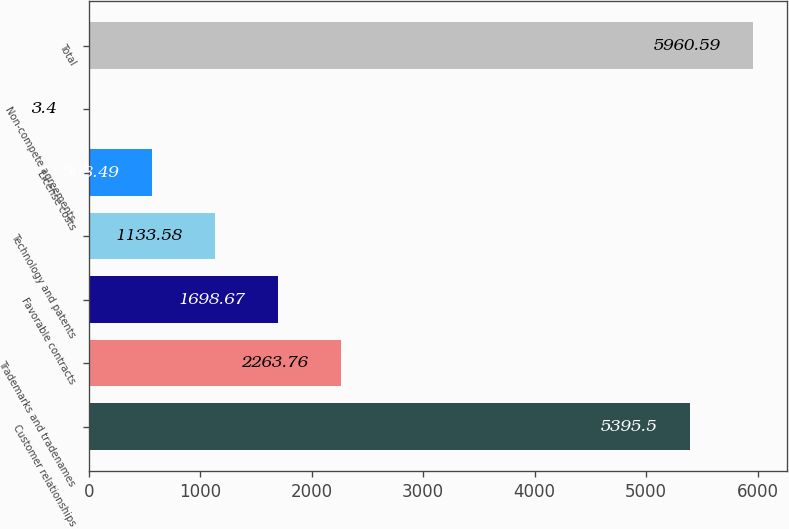<chart> <loc_0><loc_0><loc_500><loc_500><bar_chart><fcel>Customer relationships<fcel>Trademarks and tradenames<fcel>Favorable contracts<fcel>Technology and patents<fcel>License costs<fcel>Non-compete agreements<fcel>Total<nl><fcel>5395.5<fcel>2263.76<fcel>1698.67<fcel>1133.58<fcel>568.49<fcel>3.4<fcel>5960.59<nl></chart> 